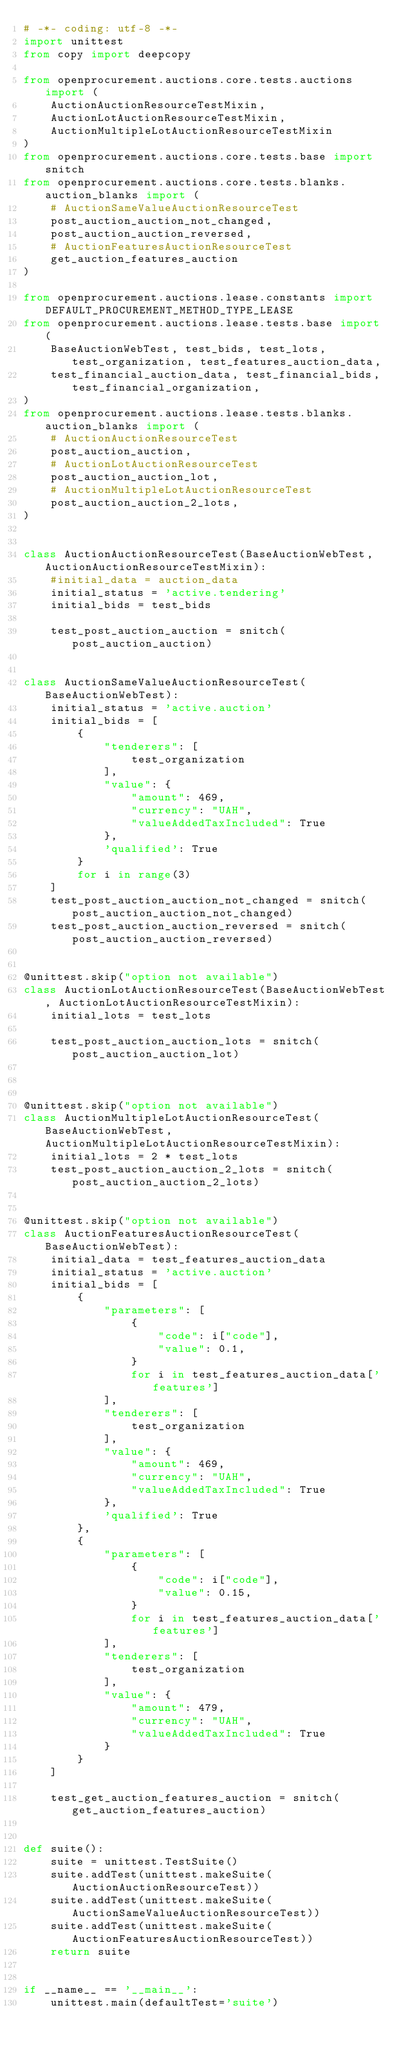Convert code to text. <code><loc_0><loc_0><loc_500><loc_500><_Python_># -*- coding: utf-8 -*-
import unittest
from copy import deepcopy

from openprocurement.auctions.core.tests.auctions import (
    AuctionAuctionResourceTestMixin,
    AuctionLotAuctionResourceTestMixin,
    AuctionMultipleLotAuctionResourceTestMixin
)
from openprocurement.auctions.core.tests.base import snitch
from openprocurement.auctions.core.tests.blanks.auction_blanks import (
    # AuctionSameValueAuctionResourceTest
    post_auction_auction_not_changed,
    post_auction_auction_reversed,
    # AuctionFeaturesAuctionResourceTest
    get_auction_features_auction
)

from openprocurement.auctions.lease.constants import DEFAULT_PROCUREMENT_METHOD_TYPE_LEASE
from openprocurement.auctions.lease.tests.base import (
    BaseAuctionWebTest, test_bids, test_lots, test_organization, test_features_auction_data,
    test_financial_auction_data, test_financial_bids, test_financial_organization,
)
from openprocurement.auctions.lease.tests.blanks.auction_blanks import (
    # AuctionAuctionResourceTest
    post_auction_auction,
    # AuctionLotAuctionResourceTest
    post_auction_auction_lot,
    # AuctionMultipleLotAuctionResourceTest
    post_auction_auction_2_lots,
)


class AuctionAuctionResourceTest(BaseAuctionWebTest, AuctionAuctionResourceTestMixin):
    #initial_data = auction_data
    initial_status = 'active.tendering'
    initial_bids = test_bids

    test_post_auction_auction = snitch(post_auction_auction)


class AuctionSameValueAuctionResourceTest(BaseAuctionWebTest):
    initial_status = 'active.auction'
    initial_bids = [
        {
            "tenderers": [
                test_organization
            ],
            "value": {
                "amount": 469,
                "currency": "UAH",
                "valueAddedTaxIncluded": True
            },
            'qualified': True
        }
        for i in range(3)
    ]
    test_post_auction_auction_not_changed = snitch(post_auction_auction_not_changed)
    test_post_auction_auction_reversed = snitch(post_auction_auction_reversed)


@unittest.skip("option not available")
class AuctionLotAuctionResourceTest(BaseAuctionWebTest, AuctionLotAuctionResourceTestMixin):
    initial_lots = test_lots

    test_post_auction_auction_lots = snitch(post_auction_auction_lot)



@unittest.skip("option not available")
class AuctionMultipleLotAuctionResourceTest(BaseAuctionWebTest, AuctionMultipleLotAuctionResourceTestMixin):
    initial_lots = 2 * test_lots
    test_post_auction_auction_2_lots = snitch(post_auction_auction_2_lots)


@unittest.skip("option not available")
class AuctionFeaturesAuctionResourceTest(BaseAuctionWebTest):
    initial_data = test_features_auction_data
    initial_status = 'active.auction'
    initial_bids = [
        {
            "parameters": [
                {
                    "code": i["code"],
                    "value": 0.1,
                }
                for i in test_features_auction_data['features']
            ],
            "tenderers": [
                test_organization
            ],
            "value": {
                "amount": 469,
                "currency": "UAH",
                "valueAddedTaxIncluded": True
            },
            'qualified': True
        },
        {
            "parameters": [
                {
                    "code": i["code"],
                    "value": 0.15,
                }
                for i in test_features_auction_data['features']
            ],
            "tenderers": [
                test_organization
            ],
            "value": {
                "amount": 479,
                "currency": "UAH",
                "valueAddedTaxIncluded": True
            }
        }
    ]

    test_get_auction_features_auction = snitch(get_auction_features_auction)


def suite():
    suite = unittest.TestSuite()
    suite.addTest(unittest.makeSuite(AuctionAuctionResourceTest))
    suite.addTest(unittest.makeSuite(AuctionSameValueAuctionResourceTest))
    suite.addTest(unittest.makeSuite(AuctionFeaturesAuctionResourceTest))
    return suite


if __name__ == '__main__':
    unittest.main(defaultTest='suite')
</code> 